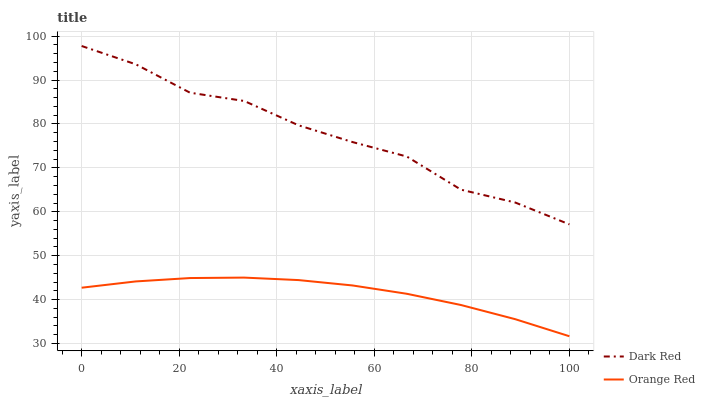Does Orange Red have the minimum area under the curve?
Answer yes or no. Yes. Does Dark Red have the maximum area under the curve?
Answer yes or no. Yes. Does Orange Red have the maximum area under the curve?
Answer yes or no. No. Is Orange Red the smoothest?
Answer yes or no. Yes. Is Dark Red the roughest?
Answer yes or no. Yes. Is Orange Red the roughest?
Answer yes or no. No. Does Orange Red have the lowest value?
Answer yes or no. Yes. Does Dark Red have the highest value?
Answer yes or no. Yes. Does Orange Red have the highest value?
Answer yes or no. No. Is Orange Red less than Dark Red?
Answer yes or no. Yes. Is Dark Red greater than Orange Red?
Answer yes or no. Yes. Does Orange Red intersect Dark Red?
Answer yes or no. No. 